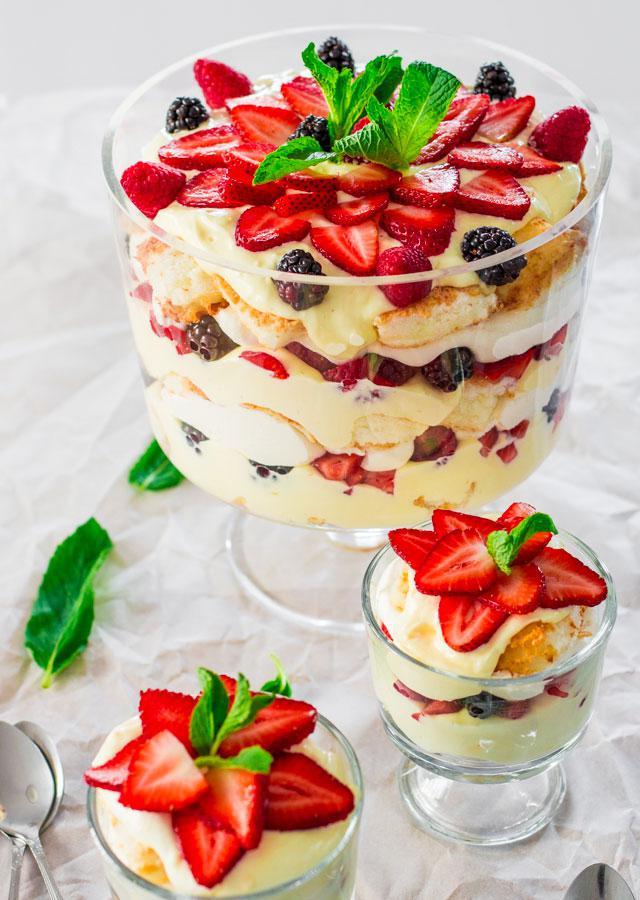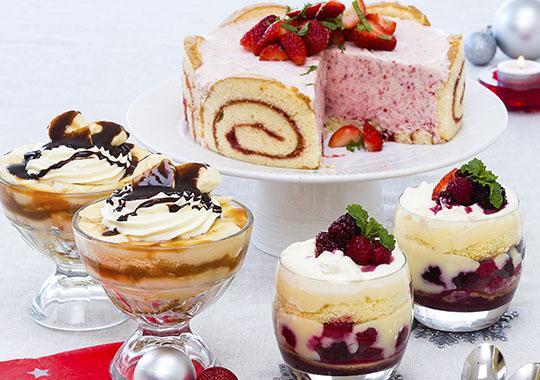The first image is the image on the left, the second image is the image on the right. Assess this claim about the two images: "An image shows a dessert garnished with red fruit that features jelly roll slices around the outer edge.". Correct or not? Answer yes or no. Yes. The first image is the image on the left, the second image is the image on the right. Assess this claim about the two images: "The cake in the image on the right has several layers.". Correct or not? Answer yes or no. No. 